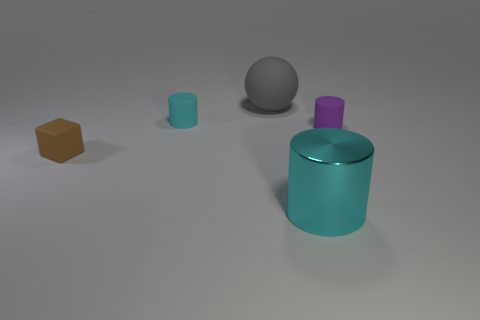What number of matte things have the same size as the cyan shiny cylinder?
Offer a very short reply. 1. There is a cylinder that is both behind the shiny cylinder and to the right of the cyan matte cylinder; what is its color?
Ensure brevity in your answer.  Purple. How many objects are large brown objects or large cylinders?
Provide a succinct answer. 1. What number of large objects are cyan objects or brown metallic objects?
Make the answer very short. 1. Is there anything else that is the same color as the metal thing?
Make the answer very short. Yes. How big is the matte object that is to the left of the gray thing and behind the tiny brown matte block?
Your answer should be very brief. Small. There is a rubber cylinder that is to the left of the tiny purple cylinder; is its color the same as the matte cylinder that is right of the sphere?
Give a very brief answer. No. How many other objects are the same material as the large gray sphere?
Give a very brief answer. 3. What is the shape of the small rubber object that is on the left side of the large metallic cylinder and on the right side of the small brown thing?
Your response must be concise. Cylinder. Does the large shiny thing have the same color as the tiny cylinder that is in front of the small cyan object?
Make the answer very short. No. 